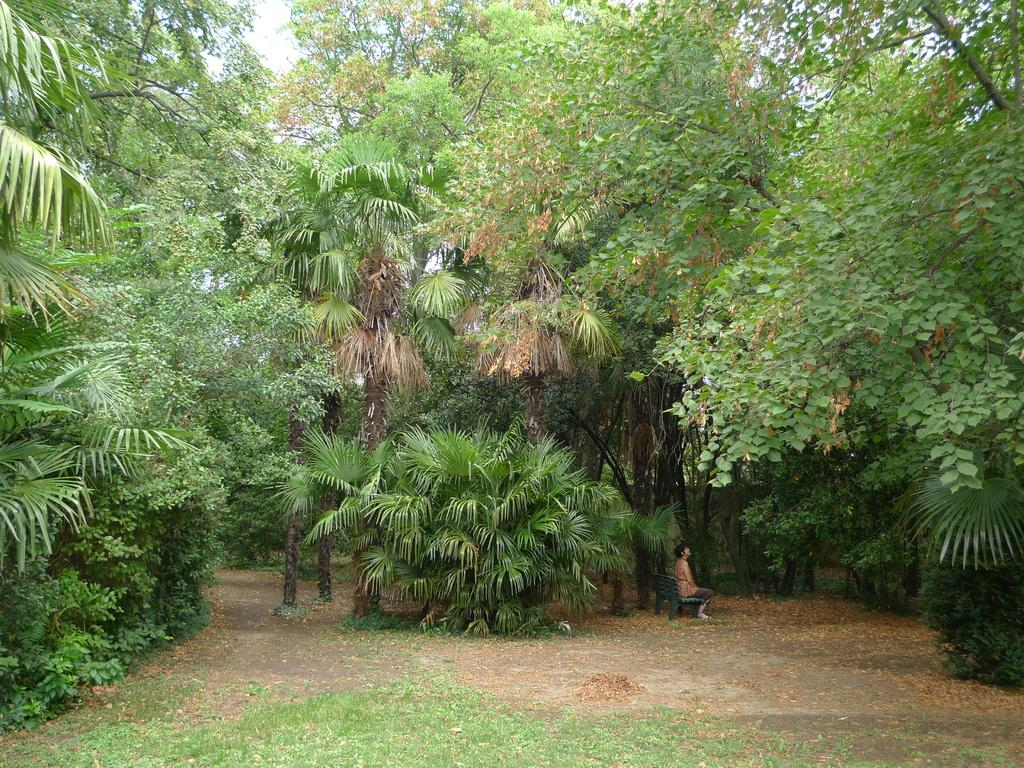What is the person in the image doing? There is a person sitting on a bench in the image. What type of surface is the person sitting on? The person is sitting on a bench in the image. What can be seen on the land in the image? There is grass on the land in the image. What is visible in the background of the image? There are plants and trees in the background of the image. How does the person in the image grip the plantation? There is no plantation present in the image, and the person is not gripping anything. 